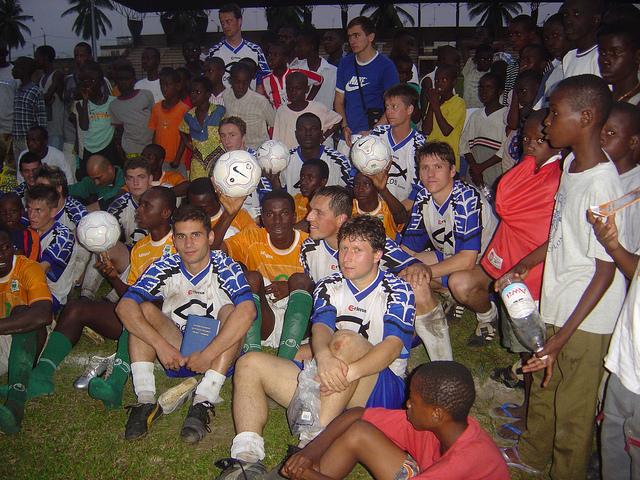How many soccer balls are in this picture?
Give a very brief answer. 4. How many feet are in the picture?
Short answer required. 11. Are all of the people the same race?
Keep it brief. No. Are they eating lunch?
Keep it brief. No. How many people in the photo?
Concise answer only. 30. Are the adults in soccer uniforms?
Be succinct. Yes. 